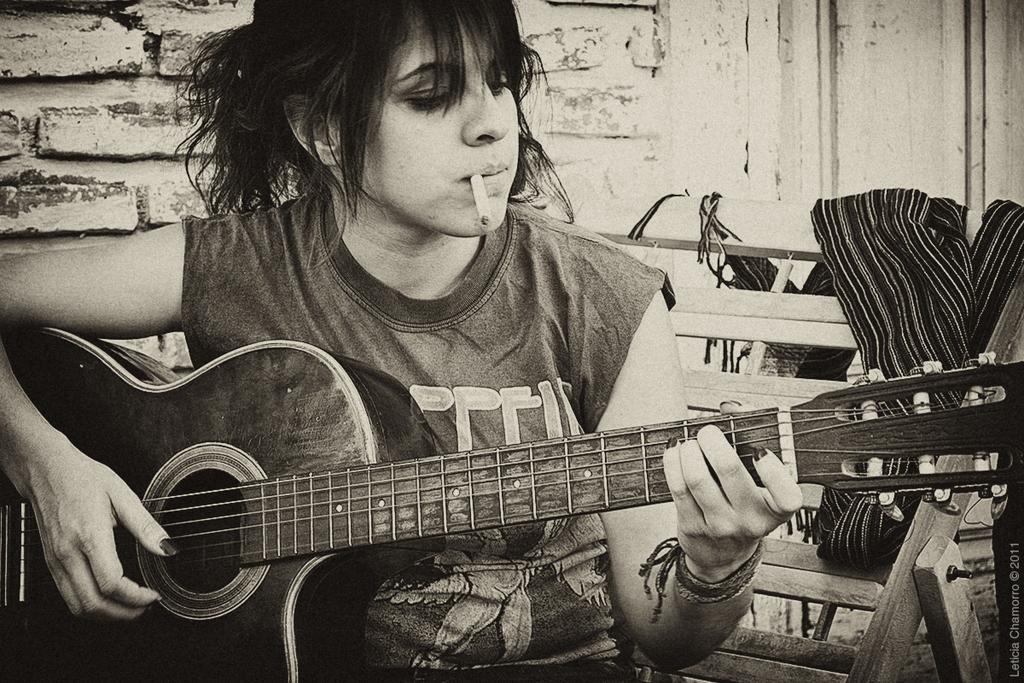Can you describe this image briefly? In this image we can see a woman sitting on a wooden chair. She is playing a guitar and she is smoking a cigarette. 